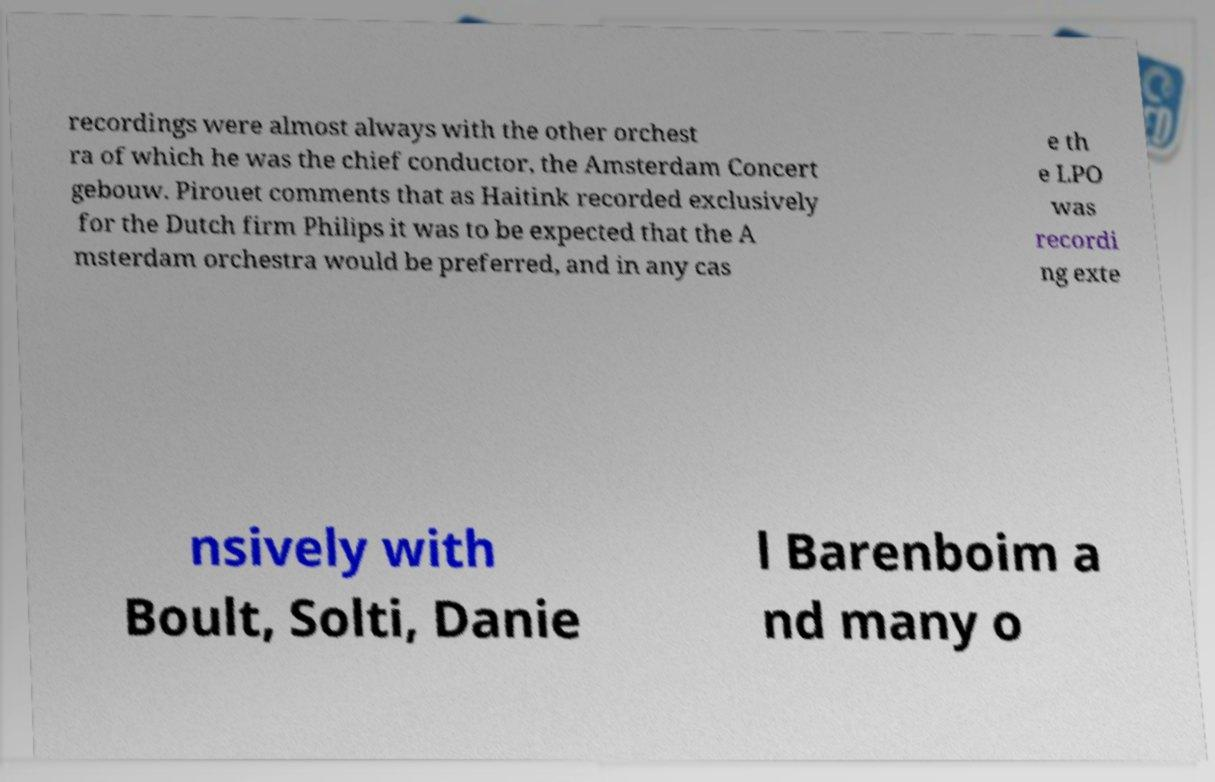Please identify and transcribe the text found in this image. recordings were almost always with the other orchest ra of which he was the chief conductor, the Amsterdam Concert gebouw. Pirouet comments that as Haitink recorded exclusively for the Dutch firm Philips it was to be expected that the A msterdam orchestra would be preferred, and in any cas e th e LPO was recordi ng exte nsively with Boult, Solti, Danie l Barenboim a nd many o 